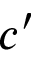<formula> <loc_0><loc_0><loc_500><loc_500>c ^ { \prime }</formula> 